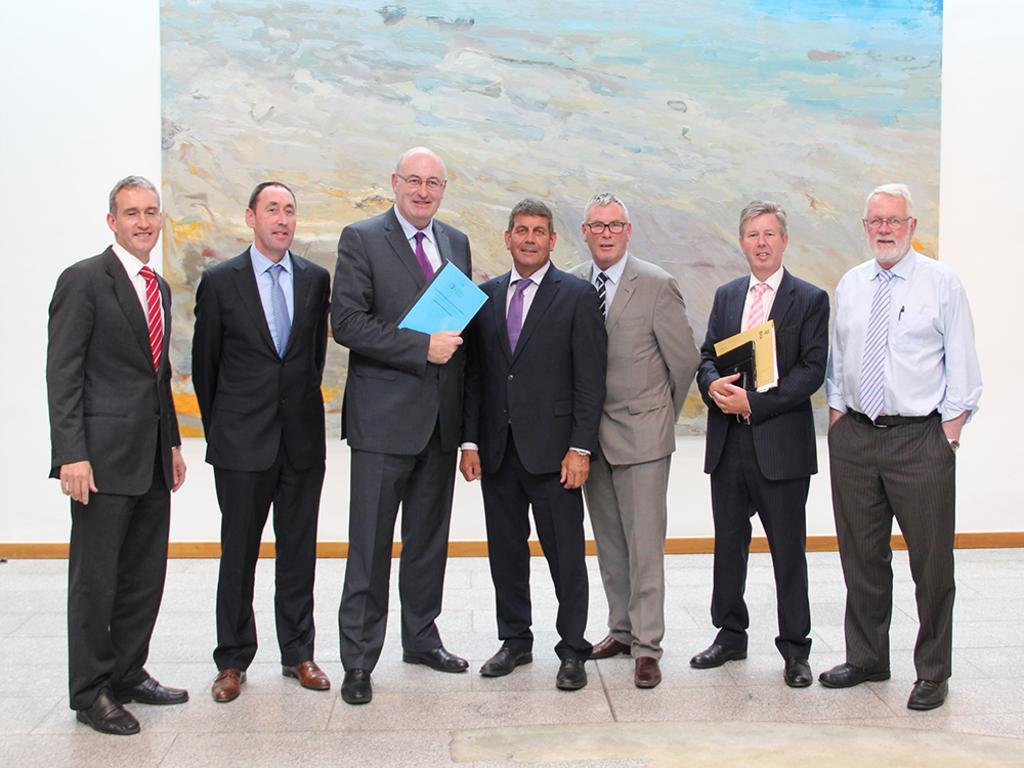Describe this image in one or two sentences. In this picture there is a bald man who is wearing spectacle, suit, trouser and shoe. He is holding the blue file. beside him there is another man who is wearing black suit, trouser and shoe. On the right there is an old man who is wearing shirt, tie, watch, trouser and shoe. In his pocket there is a pen, beside him there is another man who is wearing shirt, blazer, trouser and shoe. He is holding the laptop and yellow file. Beside him we can see another man who is wearing grey, suit, spectacle, trouser and shoe. On the left there is another man who is smiling, beside him we can see another man who is wearing suit, trouser and brown shoe. they are standing on the floor. In the back there is a painting on the wall. 